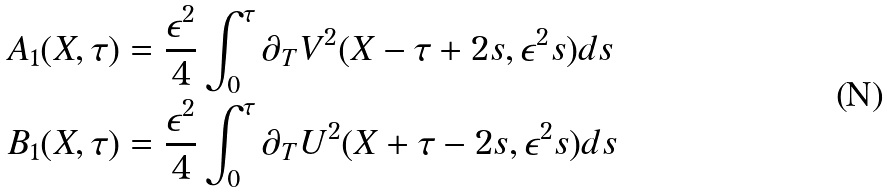<formula> <loc_0><loc_0><loc_500><loc_500>A _ { 1 } ( X , \tau ) & = \frac { \epsilon ^ { 2 } } { 4 } \int ^ { \tau } _ { 0 } \partial _ { T } V ^ { 2 } ( X - \tau + 2 s , \epsilon ^ { 2 } s ) d s \\ B _ { 1 } ( X , \tau ) & = \frac { \epsilon ^ { 2 } } { 4 } \int ^ { \tau } _ { 0 } \partial _ { T } U ^ { 2 } ( X + \tau - 2 s , \epsilon ^ { 2 } s ) d s \\</formula> 